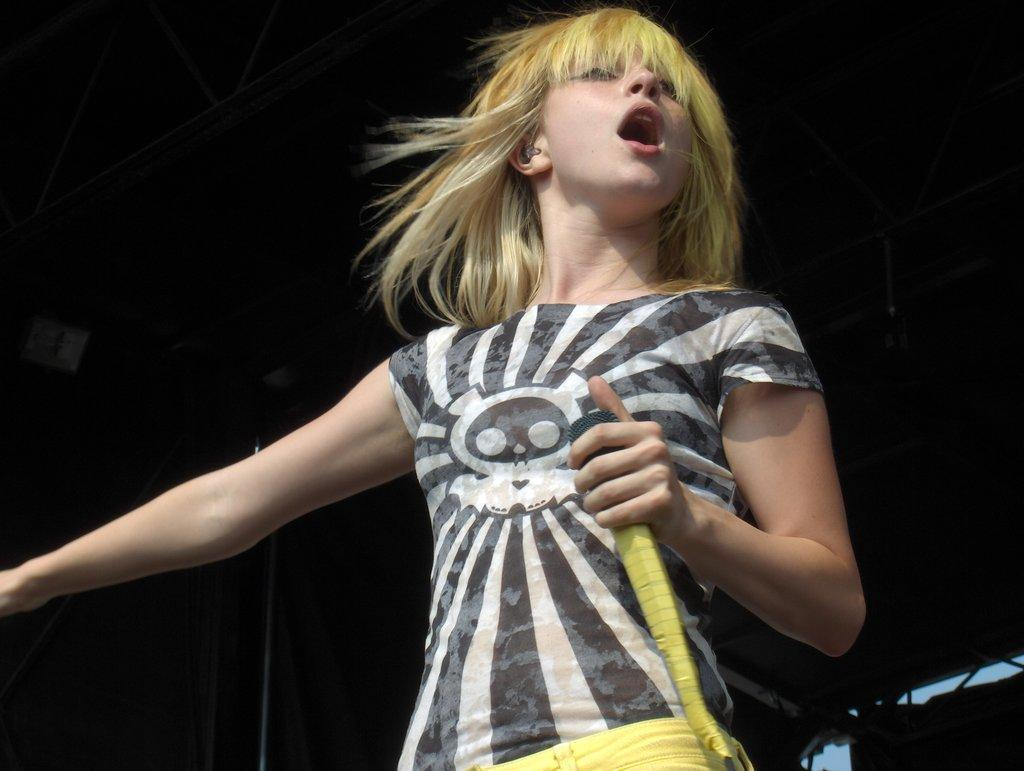Who is the main subject in the image? There is a girl in the image. Can you describe the girl's appearance? The girl has short hair. Where is the girl located in the image? The girl is at the center of the image. What is the girl doing in the image? The girl is watching to the left side of the image. What is the girl holding in her hand? The girl is holding a mic in her hand. What can be inferred about the setting of the image? The setting appears to be a stage. Can you hear the snake making a sound in the image? There is no snake present in the image, so it is not possible to hear any sounds made by a snake. 